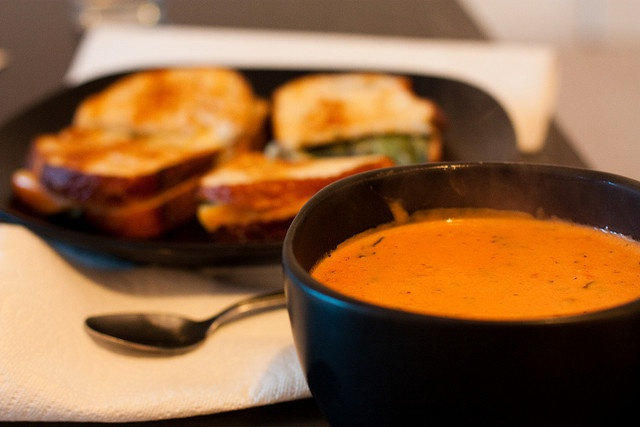Describe the objects in this image and their specific colors. I can see bowl in brown, black, orange, and maroon tones, sandwich in brown, maroon, and orange tones, sandwich in brown, orange, and olive tones, sandwich in brown, black, and red tones, and spoon in brown, black, and maroon tones in this image. 